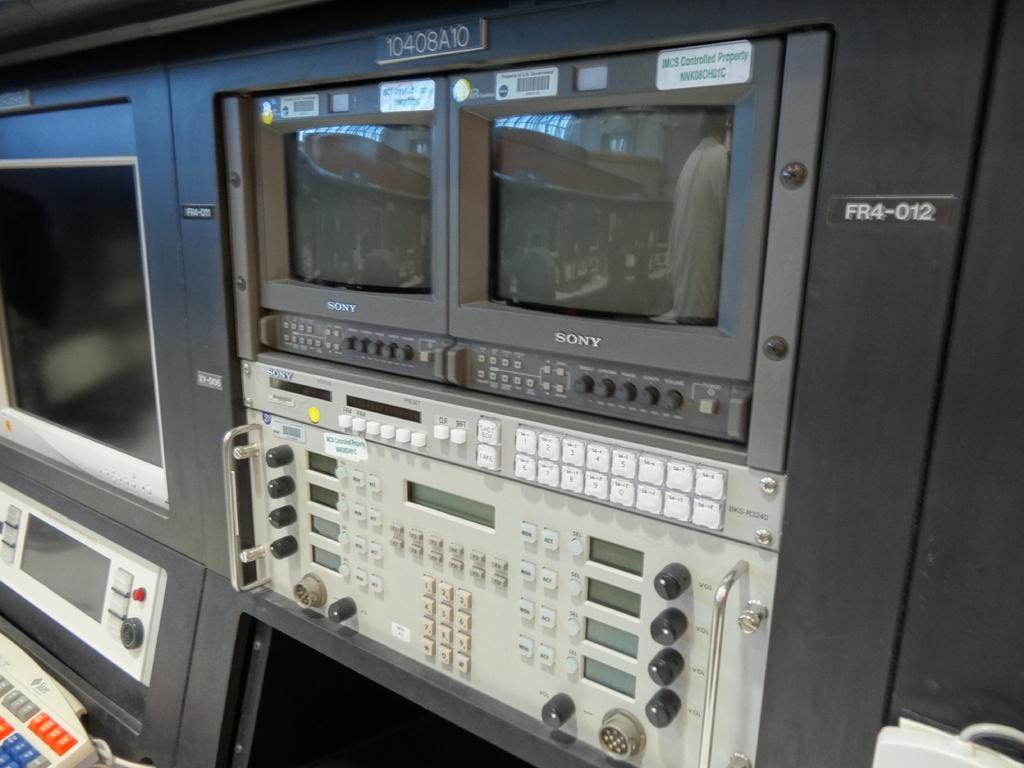<image>
Give a short and clear explanation of the subsequent image. A dual monitor system attached to a switch board on the wall by Sony. 